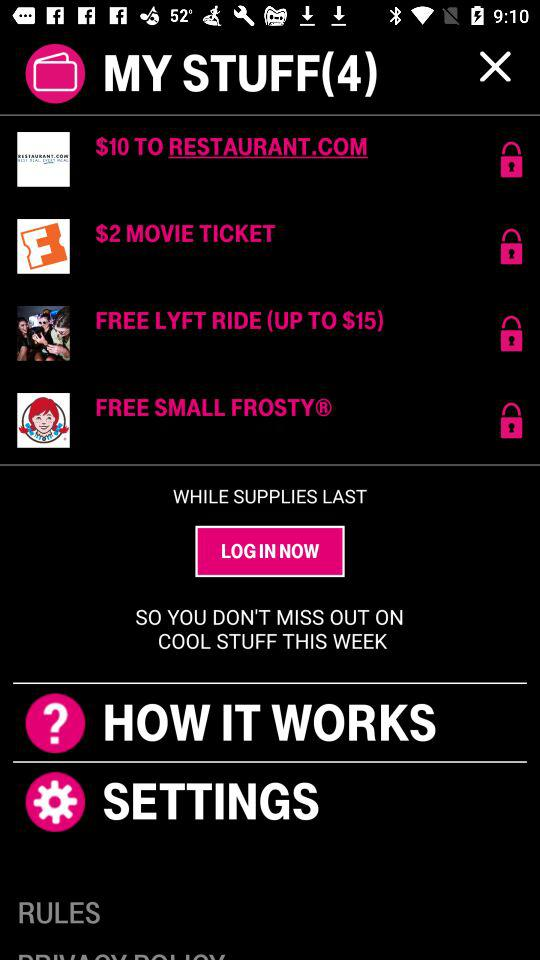How many rewards do I have?
Answer the question using a single word or phrase. 4 